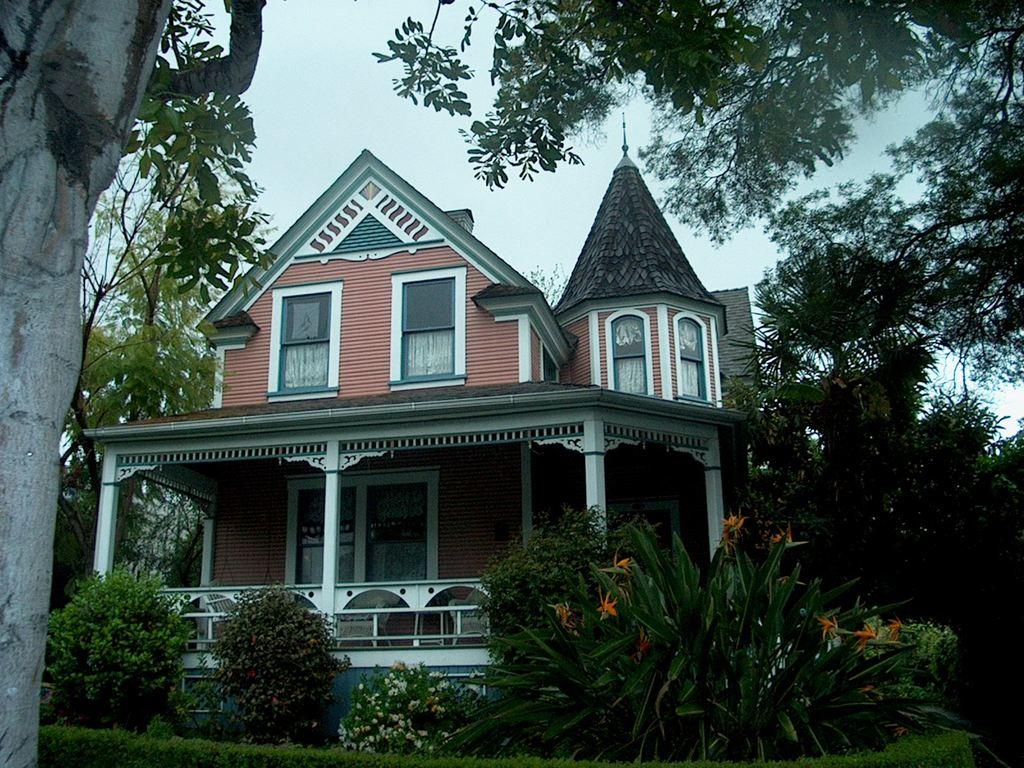Where was the image taken? The image was taken outside. What is the main subject in the middle of the image? There is a building in the middle of the image. What type of vegetation can be seen on the left side of the image? There are trees on the left side of the image. What type of vegetation can be seen on the right side of the image? There are trees on the right side of the image. What is visible at the bottom of the image? There are bushes at the bottom of the image. What is visible at the top of the image? The sky is visible at the top of the image. What is the order of the planets in the image? There are no planets visible in the image; it features a building, trees, bushes, and the sky. What belief system is represented by the trees in the image? The image does not represent any specific belief system; it simply shows trees as part of the natural environment. 